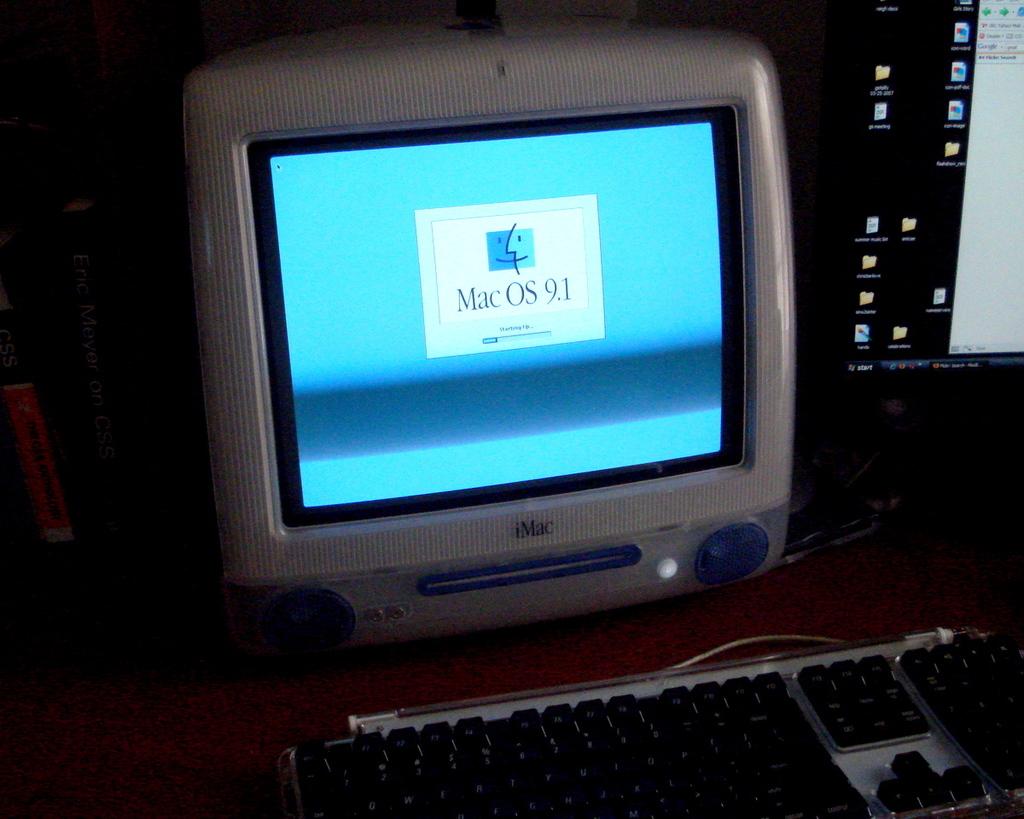What version of mac is this?
Make the answer very short. 9.1. 